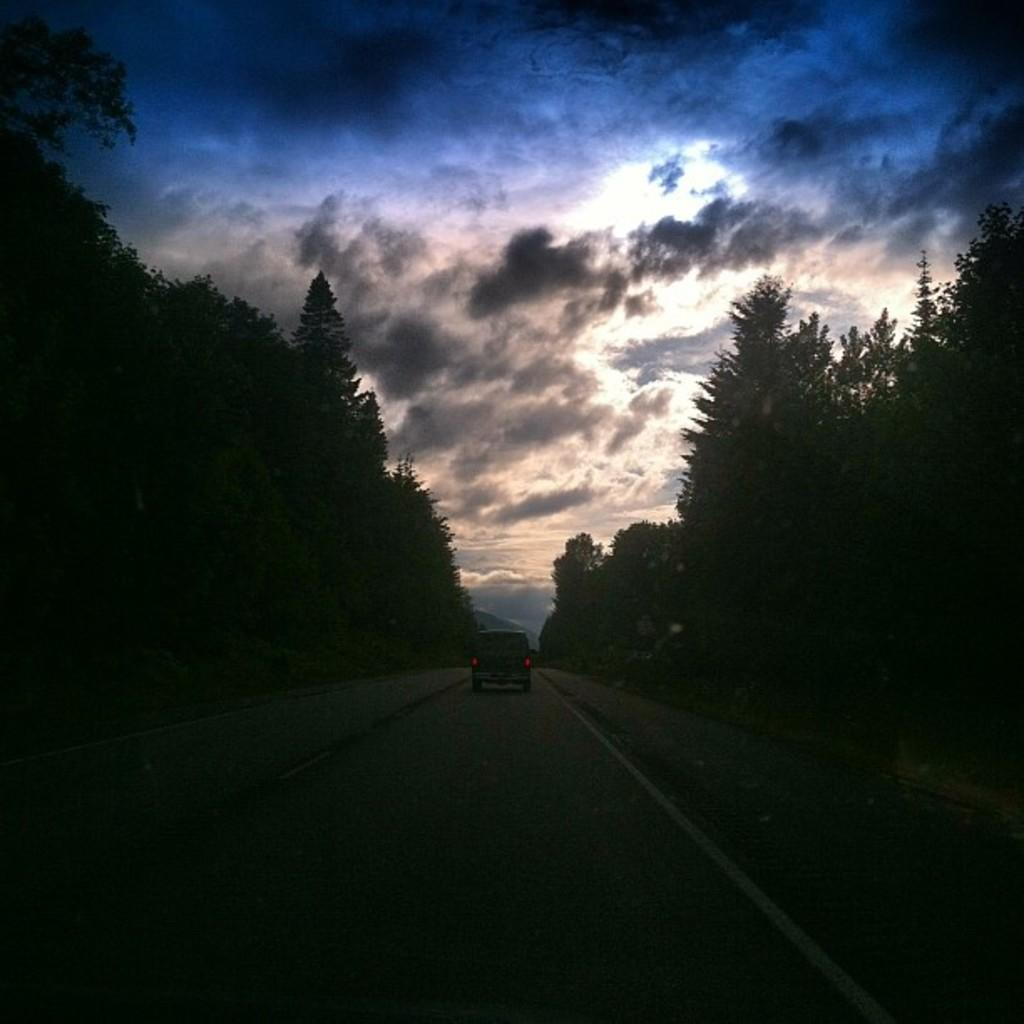What is the main subject in the center of the image? There is a vehicle in the center of the image. Where is the vehicle located? The vehicle is on the road. What can be seen on both sides of the road in the image? There are trees on both the right and left sides of the image. What is visible in the background of the image? There are clouds and the sky visible in the background of the image. What type of flesh can be seen hanging from the trees in the image? There is no flesh visible in the image; it features a vehicle on the road with trees on both sides and a cloudy sky in the background. 